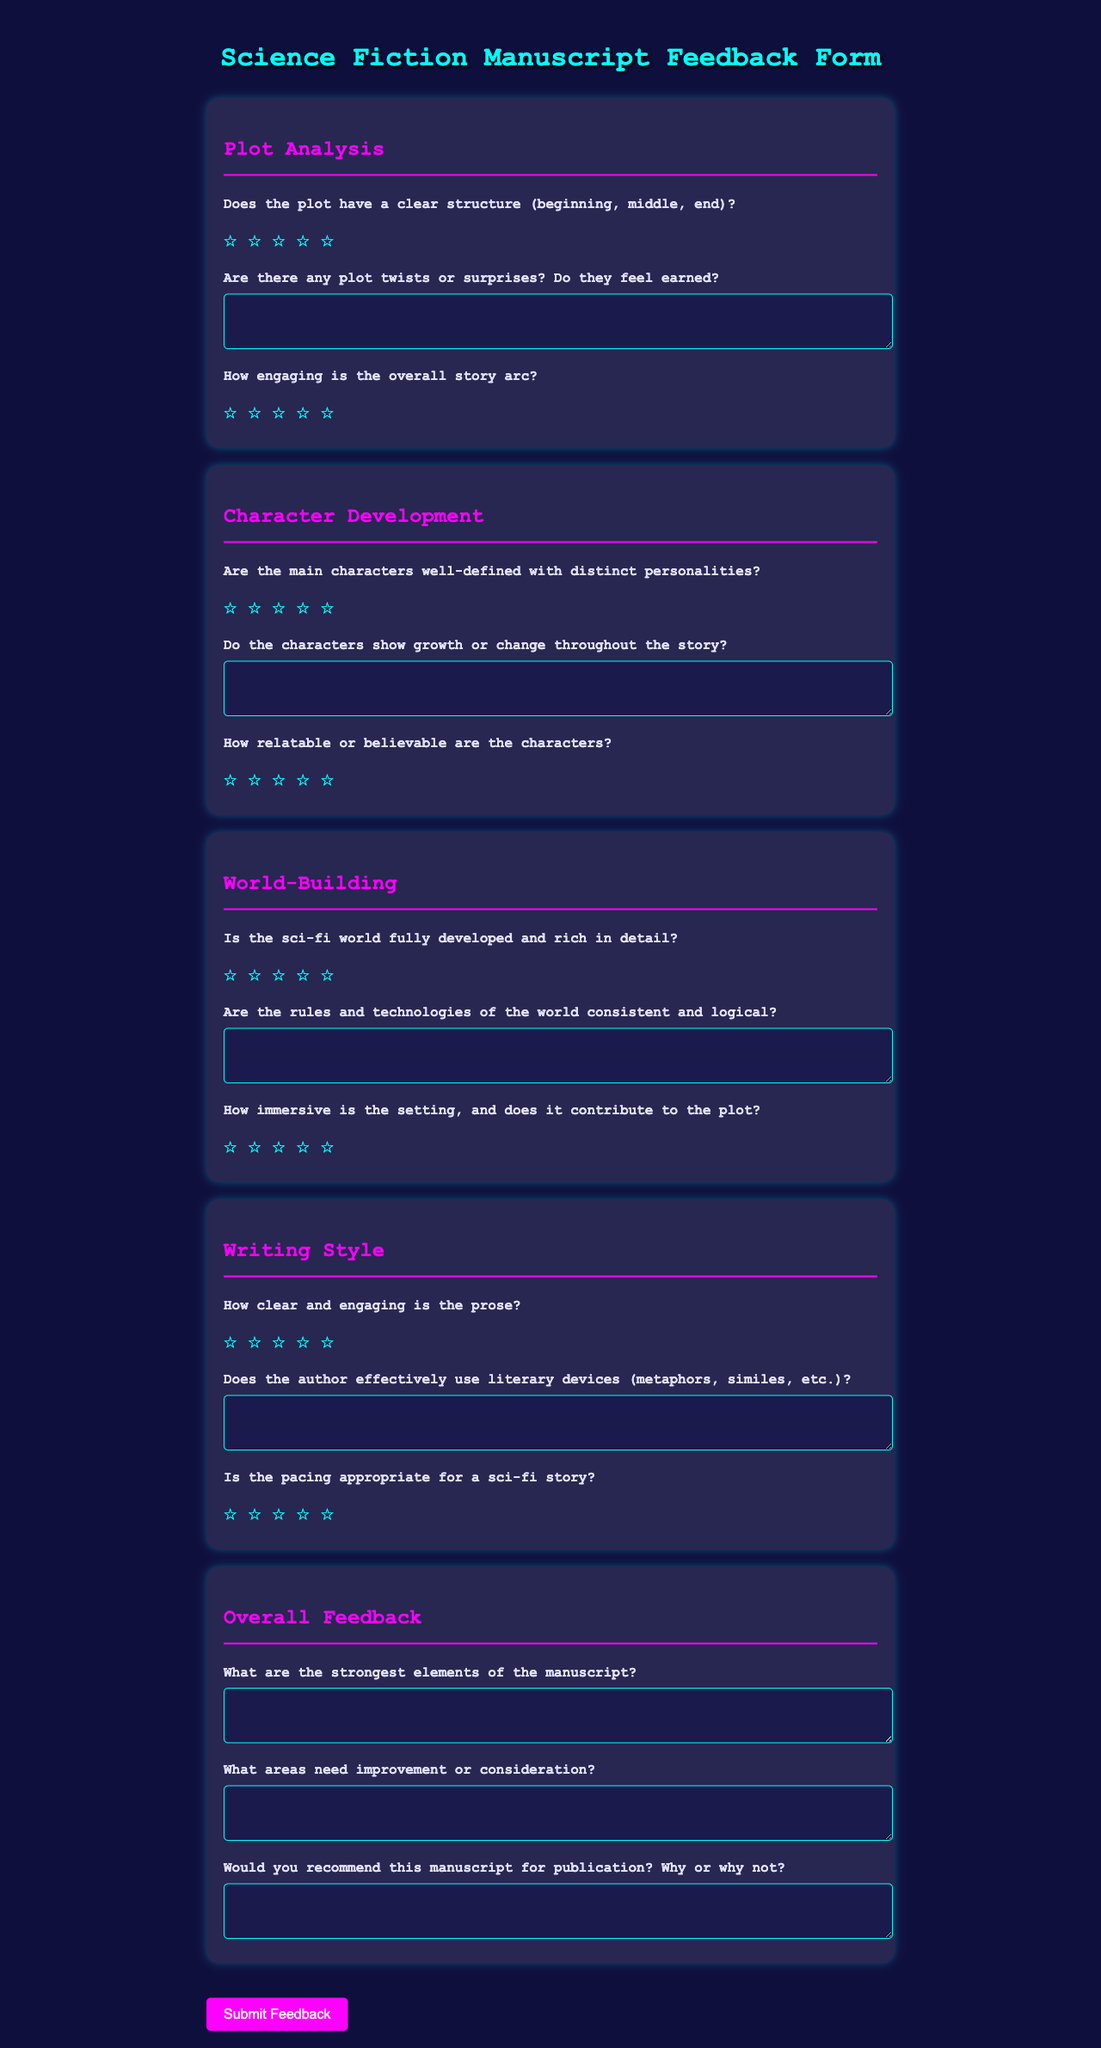What is the title of the feedback form? The title is displayed prominently at the top of the document.
Answer: Science Fiction Manuscript Feedback Form How many sections are in the feedback form? The document contains multiple sections for different aspects of the manuscript.
Answer: Four What color is the background of the form? The background color is specified in the document's styling.
Answer: Dark blue What feedback rating scale is used in the form? The form uses a specific symbol for rating, indicated in the styling.
Answer: Star What is asked in the last question of the overall feedback section? The last question seeks a specific recommendation regarding the manuscript’s publication.
Answer: Would you recommend this manuscript for publication? Why or why not? How many open-ended questions are present in the feedback form? The number of open-ended questions can be counted in the overall feedback section.
Answer: Three What is the main purpose of the "World-Building" section? This section focuses on aspects related to the creation of the story's fictional universe.
Answer: To evaluate the world’s detail and consistency What type of response is expected for "Are there any plot twists or surprises? Do they feel earned?" This is an open-ended question that requires written feedback.
Answer: Text response 